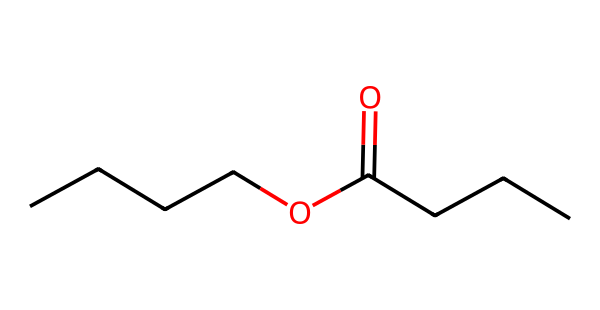How many carbon atoms are in butyl butyrate? The SMILES representation shows four 'C' symbols in the butyl group (CCCC) and includes three 'C' symbols in the butyrate portion (C(=O)CCC). Adding these gives a total of seven carbon atoms.
Answer: seven What is the functional group present in butyl butyrate? The formula indicates an ester group due to the presence of 'OC(=O)' in the SMILES, which is characteristic of esters.
Answer: ester How many oxygen atoms are present in butyl butyrate? The SMILES representation contains two 'O' symbols, indicating there are two oxygen atoms in the structure.
Answer: two What type of odor is generally associated with butyl butyrate? Butyl butyrate is known for its fruity aroma, which is commonly used in air fresheners and flavorings.
Answer: fruity What is the total number of hydrogen atoms in butyl butyrate? To find the hydrogen count, we consider the structure: the butyl group contributes nine hydrogens (C4H9) and the butyrate group contributes five when accounting for the ester bond, giving a total of fourteen hydrogen atoms.
Answer: fourteen Is butyl butyrate soluble in water? Esters like butyl butyrate are generally lipophilic and have low solubility in water, despite having the ability to mix with organic solvents.
Answer: low What type of reaction is involved in the formation of butyl butyrate? The formation of butyl butyrate involves a condensation reaction between an alcohol (butanol) and a carboxylic acid (butyric acid), typically releasing water.
Answer: condensation 